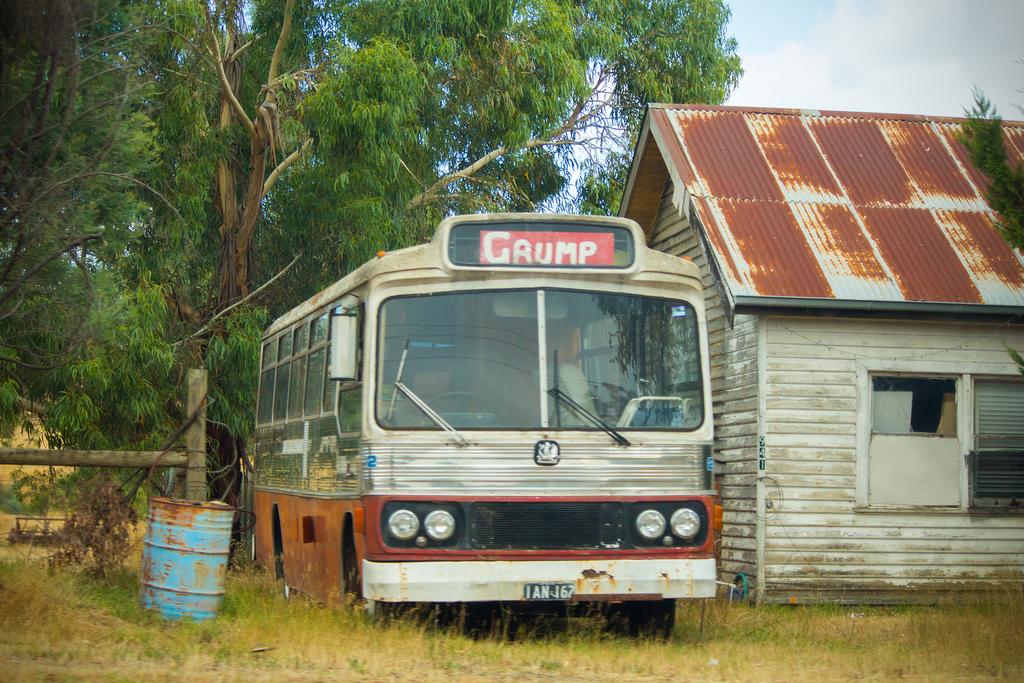What is the name of the bus?
Provide a short and direct response. Grump. What is the plate number?
Provide a short and direct response. Ian 167. 